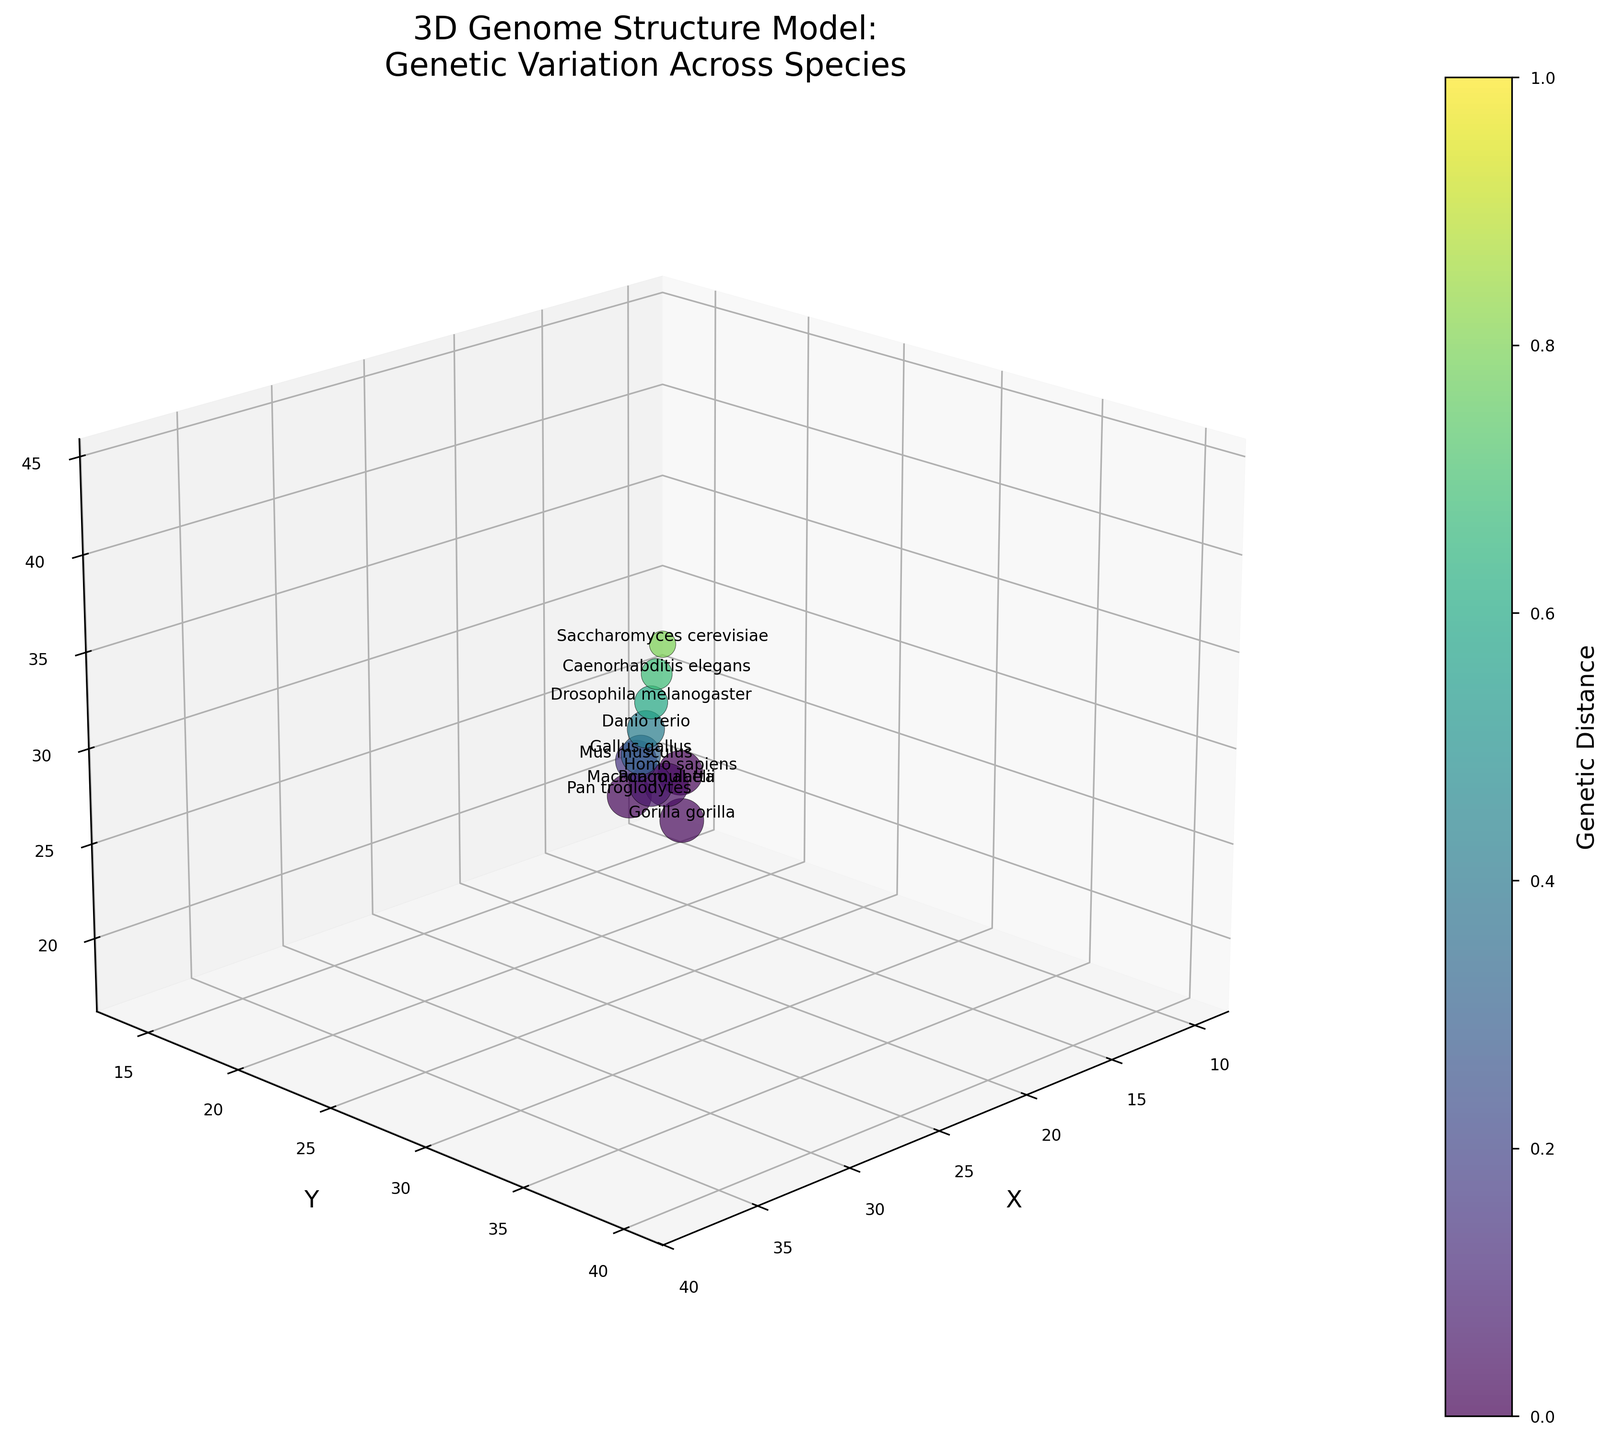How many species are represented in the figure? Count the number of unique species labels in the plot. There are 11 species listed.
Answer: 11 What are the axes labels in the plot? The figure has labeled axes as follows: X, Y, and Z. Each label can be seen next to its respective axis.
Answer: X, Y, Z Which species has the highest genome complexity? Observe the size of the points in the plot: the species with the largest points represent higher genome complexity. Homo sapiens has the largest point size.
Answer: Homo sapiens What is the title of the figure? The title is located at the top of the figure, and it reads: "3D Genome Structure Model: Genetic Variation Across Species."
Answer: 3D Genome Structure Model: Genetic Variation Across Species How does the genetic distance vary with color? The color gradient in the figure, shown by the color bar, indicates genetic distance, with lighter colors representing greater distances.
Answer: Lighter colors represent greater genetic distances Which species has the lowest genetic distance from Homo sapiens? Compare the colors of the species points. The closest match in color to Homo sapiens, which has the darkest color, is Pan troglodytes.
Answer: Pan troglodytes Which two species are closest in the 3D space (X, Y, Z coordinates)? By visually inspecting the 3D plot, the species that appear closest to each other in the 3D space are Homo sapiens and Pan troglodytes.
Answer: Homo sapiens and Pan troglodytes Do genome complexity and genetic distance positively correlate based on the scatter plot? By observing the figure, larger points generally have darker colors, indicating higher genome complexity correlates with lower genetic distance.
Answer: No Which species is represented by the point at X=30, Y=32, Z=36? Locate the point with coordinates (30, 32, 36) on the 3D plot and read the corresponding species label. This point is for Drosophila melanogaster.
Answer: Drosophila melanogaster What's the genetic distance of the species at coordinates X=26, Y=28, Z=32? Find the point at coordinates (26, 28, 32) and refer to the corresponding genetic distance value from the color gradient or the raw data. This point corresponds to Danio rerio, with a genetic distance of 0.42.
Answer: 0.42 